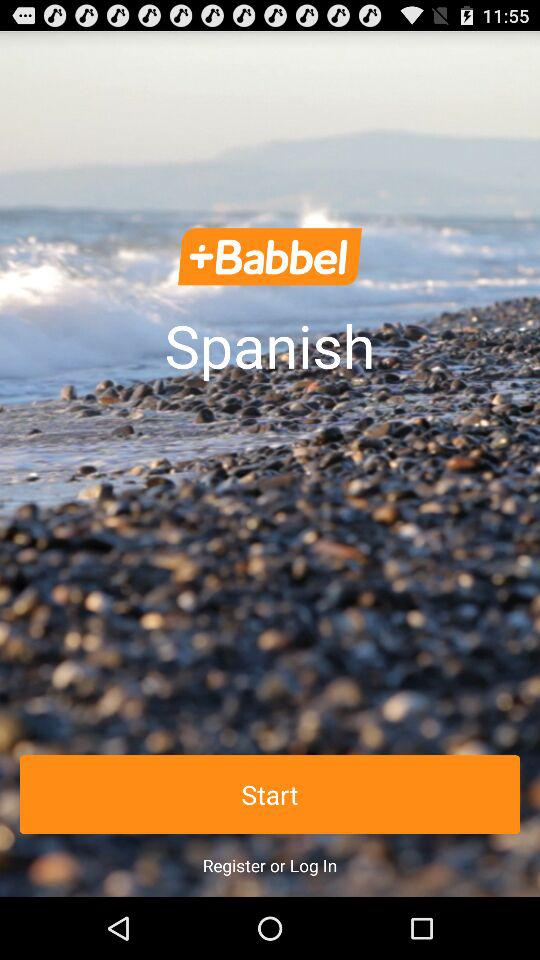What is the name of the application? The name of the application is "Babbel". 